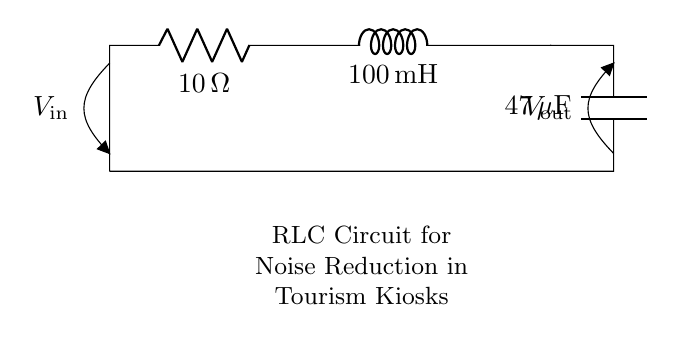What is the resistance in this circuit? The resistance is represented by the symbol R, which is specified as 10 ohms in the diagram.
Answer: 10 ohms What is the inductance value in this circuit? The inductance is denoted by the symbol L, and the diagram shows it as 100 millihenries.
Answer: 100 millihenries What is the capacitance value in this circuit? The capacitance is indicated by the symbol C, which is labeled as 47 microfarads in the diagram.
Answer: 47 microfarads What type of circuit is represented here? The circuit contains a resistor, inductor, and capacitor connected in series, which qualifies it as an RLC circuit.
Answer: RLC circuit How does the RLC circuit help in noise reduction? The combination of resistor, inductor, and capacitor can filter out high-frequency noise, thus improving signal quality in the kiosks.
Answer: Filter high-frequency noise What is the relationship between the input and output voltages in this circuit? The output voltage is impacted by the impedance created by the resistance, inductance, and capacitance, affecting how much noise is reduced.
Answer: Affected by impedance How does changing the inductance value influence noise reduction? Increasing the inductance can improve the filtering of lower frequency noise, thus enhancing the circuit's noise reduction capability.
Answer: Improve lower frequency filtering 